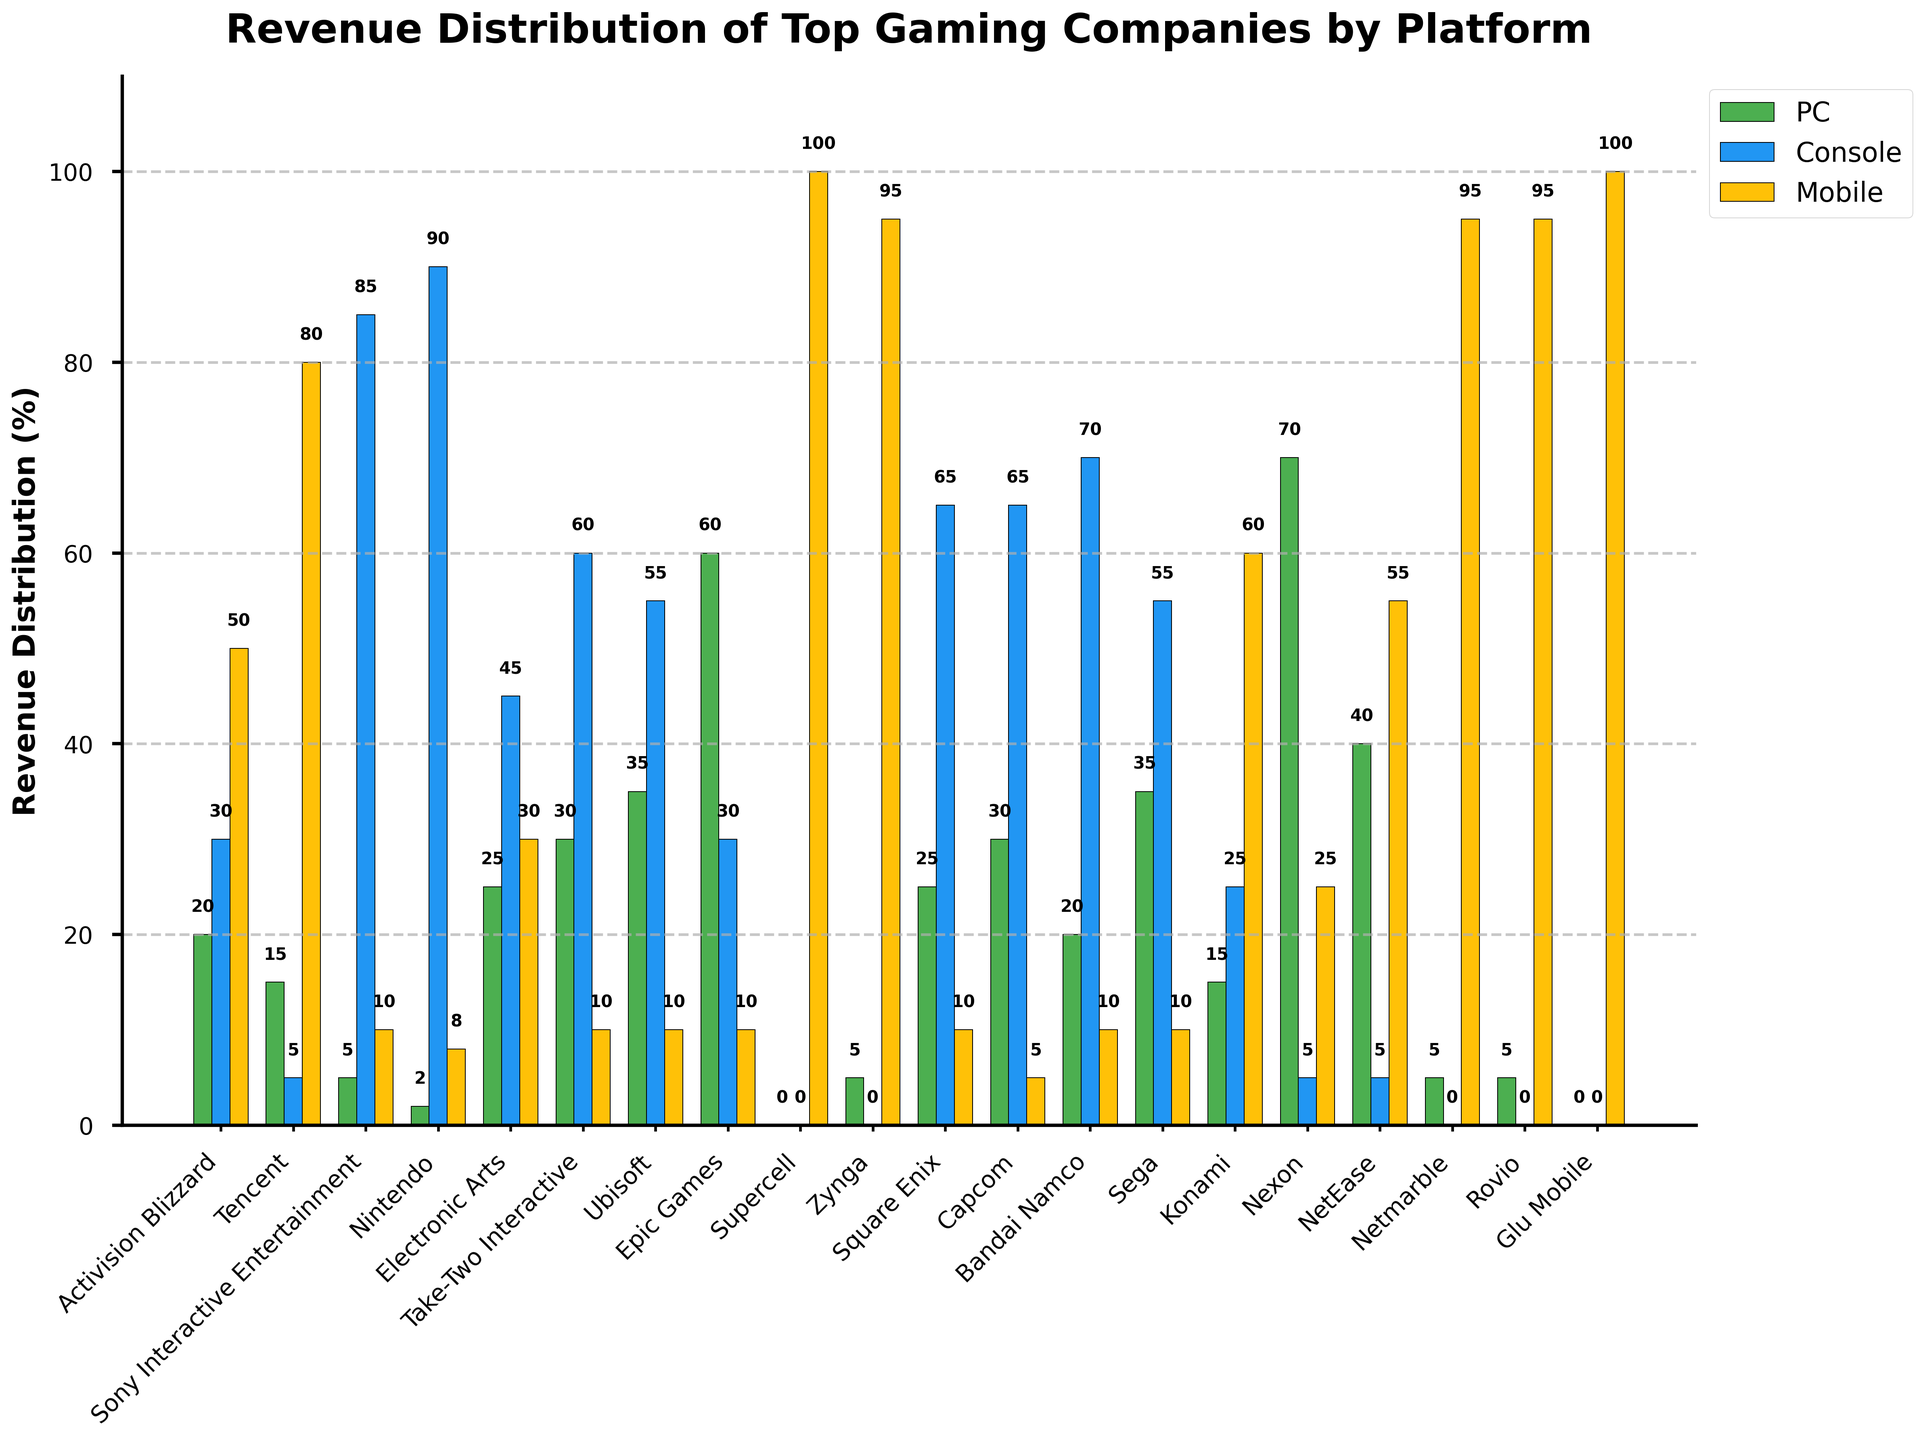Which company has the highest percentage of mobile revenue? Observe the heights of the yellow bars to identify which is the tallest. Supercell, Zynga, Netmarble, and Glu Mobile have the highest mobile revenue, each with 100%.
Answer: Supercell, Zynga, Netmarble, and Glu Mobile Which company generates more revenue from PC than mobile? Compare the heights of the green and yellow bars for each company, and identify those where the green bar (PC) is taller than the yellow bar (mobile). Examples include Epic Games, Ubisoft, and Nexon.
Answer: Epic Games, Ubisoft, Nexon Which two companies have the most similar revenue distributions across all three platforms? Look for companies with similar bar heights (green, blue, and yellow) across their three revenue streams. Square Enix and Capcom both have a distribution of approximately 25% PC, 65% console, and 10% mobile revenue.
Answer: Square Enix, Capcom What is the average mobile revenue percentage among all listed companies? Add up all the mobile revenue percentages and then divide by the number of companies (20). (50 + 80 + 10 + 8 + 30 + 10 + 10 + 10 + 100 + 95 + 10 + 5 + 10 + 10 + 60 + 25 + 55 + 95 + 95 + 100) / 20 = 871/20 = 43.55%
Answer: 43.55% Which company has the lowest percentage of console revenue? Identify the smallest blue bar. Supercell and Glu Mobile do not have console revenue, both at 0%.
Answer: Supercell and Glu Mobile Among Activision Blizzard, Tencent, and Electronic Arts, which company has the highest console revenue percentage? Compare the heights of the blue bars for these three companies, identifying the tallest one. Activision Blizzard is at 30%, Tencent at 5%, and Electronic Arts at 45%. The highest is 45%.
Answer: Electronic Arts Which company has 70% console revenue and 10% mobile revenue? Look for a company with a blue bar at 70% and a yellow bar at 10%. Bandai Namco fits this profile.
Answer: Bandai Namco How much higher is Nintendo's console revenue percentage compared to Tencent's console revenue percentage? Subtract Tencent's console revenue percentage from Nintendo's. Nintendo has 90%, Tencent has 5%. 90% - 5% = 85% higher.
Answer: 85% Which company relies solely on revenue from one platform, and what is that platform? Identify any company with one bar reaching 100% while the other two are at 0%. Supercell, Zynga, Netmarble, Rovio, and Glu Mobile rely entirely on mobile revenue.
Answer: Supercell, Zynga, Netmarble, Rovio, Glu Mobile, mobile 